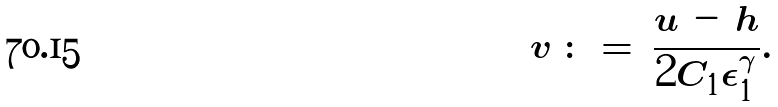<formula> <loc_0><loc_0><loc_500><loc_500>v \, \colon = \, \frac { u \, - \, h } { 2 C _ { 1 } \epsilon _ { 1 } ^ { \gamma } } .</formula> 